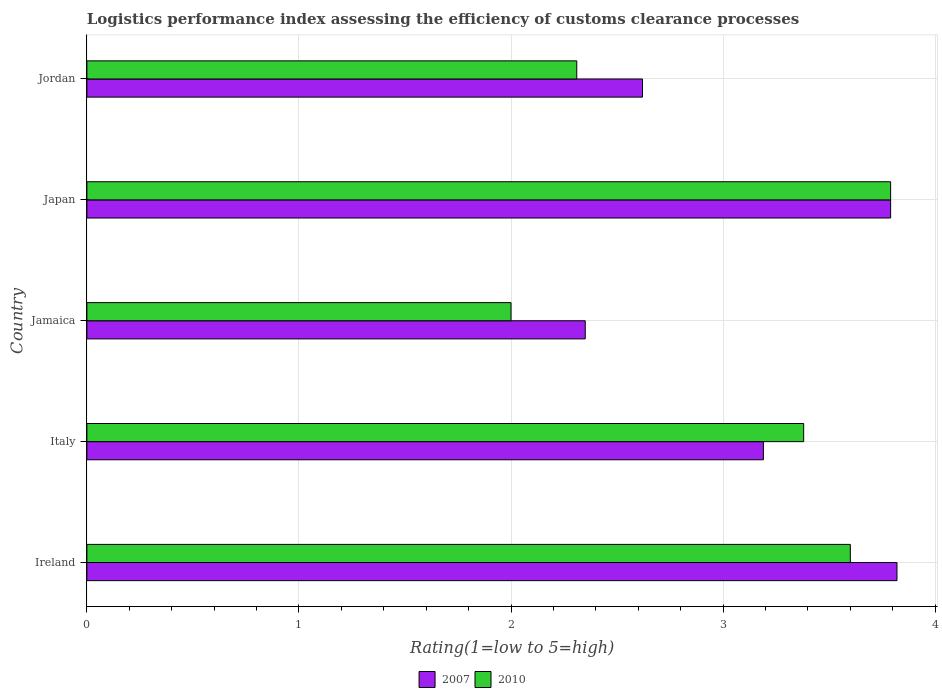How many different coloured bars are there?
Ensure brevity in your answer.  2. How many groups of bars are there?
Keep it short and to the point. 5. Are the number of bars per tick equal to the number of legend labels?
Offer a terse response. Yes. What is the label of the 5th group of bars from the top?
Provide a succinct answer. Ireland. What is the Logistic performance index in 2010 in Italy?
Offer a terse response. 3.38. Across all countries, what is the maximum Logistic performance index in 2010?
Make the answer very short. 3.79. In which country was the Logistic performance index in 2007 maximum?
Provide a short and direct response. Ireland. In which country was the Logistic performance index in 2007 minimum?
Give a very brief answer. Jamaica. What is the total Logistic performance index in 2007 in the graph?
Provide a succinct answer. 15.77. What is the difference between the Logistic performance index in 2010 in Italy and that in Jamaica?
Your answer should be very brief. 1.38. What is the difference between the Logistic performance index in 2007 in Jamaica and the Logistic performance index in 2010 in Jordan?
Provide a succinct answer. 0.04. What is the average Logistic performance index in 2007 per country?
Provide a short and direct response. 3.15. What is the difference between the Logistic performance index in 2007 and Logistic performance index in 2010 in Jordan?
Provide a short and direct response. 0.31. In how many countries, is the Logistic performance index in 2010 greater than 3.2 ?
Your answer should be very brief. 3. What is the ratio of the Logistic performance index in 2007 in Italy to that in Japan?
Provide a succinct answer. 0.84. Is the Logistic performance index in 2007 in Jamaica less than that in Jordan?
Keep it short and to the point. Yes. What is the difference between the highest and the second highest Logistic performance index in 2007?
Ensure brevity in your answer.  0.03. What is the difference between the highest and the lowest Logistic performance index in 2010?
Ensure brevity in your answer.  1.79. What does the 1st bar from the top in Jordan represents?
Give a very brief answer. 2010. How many bars are there?
Provide a short and direct response. 10. Are all the bars in the graph horizontal?
Make the answer very short. Yes. How many countries are there in the graph?
Your answer should be very brief. 5. Does the graph contain any zero values?
Keep it short and to the point. No. Does the graph contain grids?
Ensure brevity in your answer.  Yes. Where does the legend appear in the graph?
Provide a succinct answer. Bottom center. How are the legend labels stacked?
Offer a terse response. Horizontal. What is the title of the graph?
Ensure brevity in your answer.  Logistics performance index assessing the efficiency of customs clearance processes. Does "1963" appear as one of the legend labels in the graph?
Provide a succinct answer. No. What is the label or title of the X-axis?
Your response must be concise. Rating(1=low to 5=high). What is the Rating(1=low to 5=high) in 2007 in Ireland?
Your response must be concise. 3.82. What is the Rating(1=low to 5=high) in 2010 in Ireland?
Give a very brief answer. 3.6. What is the Rating(1=low to 5=high) in 2007 in Italy?
Keep it short and to the point. 3.19. What is the Rating(1=low to 5=high) in 2010 in Italy?
Offer a very short reply. 3.38. What is the Rating(1=low to 5=high) of 2007 in Jamaica?
Make the answer very short. 2.35. What is the Rating(1=low to 5=high) of 2010 in Jamaica?
Ensure brevity in your answer.  2. What is the Rating(1=low to 5=high) of 2007 in Japan?
Offer a very short reply. 3.79. What is the Rating(1=low to 5=high) in 2010 in Japan?
Make the answer very short. 3.79. What is the Rating(1=low to 5=high) in 2007 in Jordan?
Make the answer very short. 2.62. What is the Rating(1=low to 5=high) of 2010 in Jordan?
Make the answer very short. 2.31. Across all countries, what is the maximum Rating(1=low to 5=high) in 2007?
Ensure brevity in your answer.  3.82. Across all countries, what is the maximum Rating(1=low to 5=high) in 2010?
Provide a succinct answer. 3.79. Across all countries, what is the minimum Rating(1=low to 5=high) in 2007?
Provide a short and direct response. 2.35. Across all countries, what is the minimum Rating(1=low to 5=high) in 2010?
Your answer should be compact. 2. What is the total Rating(1=low to 5=high) of 2007 in the graph?
Offer a very short reply. 15.77. What is the total Rating(1=low to 5=high) of 2010 in the graph?
Offer a terse response. 15.08. What is the difference between the Rating(1=low to 5=high) of 2007 in Ireland and that in Italy?
Offer a terse response. 0.63. What is the difference between the Rating(1=low to 5=high) in 2010 in Ireland and that in Italy?
Keep it short and to the point. 0.22. What is the difference between the Rating(1=low to 5=high) in 2007 in Ireland and that in Jamaica?
Your answer should be compact. 1.47. What is the difference between the Rating(1=low to 5=high) in 2010 in Ireland and that in Jamaica?
Ensure brevity in your answer.  1.6. What is the difference between the Rating(1=low to 5=high) in 2010 in Ireland and that in Japan?
Your response must be concise. -0.19. What is the difference between the Rating(1=low to 5=high) of 2010 in Ireland and that in Jordan?
Your answer should be compact. 1.29. What is the difference between the Rating(1=low to 5=high) in 2007 in Italy and that in Jamaica?
Your answer should be compact. 0.84. What is the difference between the Rating(1=low to 5=high) in 2010 in Italy and that in Jamaica?
Ensure brevity in your answer.  1.38. What is the difference between the Rating(1=low to 5=high) of 2010 in Italy and that in Japan?
Your answer should be compact. -0.41. What is the difference between the Rating(1=low to 5=high) of 2007 in Italy and that in Jordan?
Keep it short and to the point. 0.57. What is the difference between the Rating(1=low to 5=high) in 2010 in Italy and that in Jordan?
Your response must be concise. 1.07. What is the difference between the Rating(1=low to 5=high) of 2007 in Jamaica and that in Japan?
Your answer should be compact. -1.44. What is the difference between the Rating(1=low to 5=high) of 2010 in Jamaica and that in Japan?
Your answer should be very brief. -1.79. What is the difference between the Rating(1=low to 5=high) in 2007 in Jamaica and that in Jordan?
Make the answer very short. -0.27. What is the difference between the Rating(1=low to 5=high) of 2010 in Jamaica and that in Jordan?
Give a very brief answer. -0.31. What is the difference between the Rating(1=low to 5=high) of 2007 in Japan and that in Jordan?
Your answer should be very brief. 1.17. What is the difference between the Rating(1=low to 5=high) of 2010 in Japan and that in Jordan?
Your answer should be very brief. 1.48. What is the difference between the Rating(1=low to 5=high) in 2007 in Ireland and the Rating(1=low to 5=high) in 2010 in Italy?
Your response must be concise. 0.44. What is the difference between the Rating(1=low to 5=high) of 2007 in Ireland and the Rating(1=low to 5=high) of 2010 in Jamaica?
Give a very brief answer. 1.82. What is the difference between the Rating(1=low to 5=high) of 2007 in Ireland and the Rating(1=low to 5=high) of 2010 in Japan?
Provide a short and direct response. 0.03. What is the difference between the Rating(1=low to 5=high) of 2007 in Ireland and the Rating(1=low to 5=high) of 2010 in Jordan?
Keep it short and to the point. 1.51. What is the difference between the Rating(1=low to 5=high) in 2007 in Italy and the Rating(1=low to 5=high) in 2010 in Jamaica?
Ensure brevity in your answer.  1.19. What is the difference between the Rating(1=low to 5=high) of 2007 in Italy and the Rating(1=low to 5=high) of 2010 in Jordan?
Your answer should be compact. 0.88. What is the difference between the Rating(1=low to 5=high) of 2007 in Jamaica and the Rating(1=low to 5=high) of 2010 in Japan?
Give a very brief answer. -1.44. What is the difference between the Rating(1=low to 5=high) of 2007 in Japan and the Rating(1=low to 5=high) of 2010 in Jordan?
Give a very brief answer. 1.48. What is the average Rating(1=low to 5=high) of 2007 per country?
Offer a very short reply. 3.15. What is the average Rating(1=low to 5=high) of 2010 per country?
Keep it short and to the point. 3.02. What is the difference between the Rating(1=low to 5=high) of 2007 and Rating(1=low to 5=high) of 2010 in Ireland?
Offer a terse response. 0.22. What is the difference between the Rating(1=low to 5=high) in 2007 and Rating(1=low to 5=high) in 2010 in Italy?
Ensure brevity in your answer.  -0.19. What is the difference between the Rating(1=low to 5=high) in 2007 and Rating(1=low to 5=high) in 2010 in Japan?
Provide a short and direct response. 0. What is the difference between the Rating(1=low to 5=high) in 2007 and Rating(1=low to 5=high) in 2010 in Jordan?
Offer a terse response. 0.31. What is the ratio of the Rating(1=low to 5=high) in 2007 in Ireland to that in Italy?
Make the answer very short. 1.2. What is the ratio of the Rating(1=low to 5=high) in 2010 in Ireland to that in Italy?
Ensure brevity in your answer.  1.07. What is the ratio of the Rating(1=low to 5=high) in 2007 in Ireland to that in Jamaica?
Offer a terse response. 1.63. What is the ratio of the Rating(1=low to 5=high) in 2007 in Ireland to that in Japan?
Your answer should be compact. 1.01. What is the ratio of the Rating(1=low to 5=high) in 2010 in Ireland to that in Japan?
Provide a short and direct response. 0.95. What is the ratio of the Rating(1=low to 5=high) in 2007 in Ireland to that in Jordan?
Your answer should be compact. 1.46. What is the ratio of the Rating(1=low to 5=high) of 2010 in Ireland to that in Jordan?
Ensure brevity in your answer.  1.56. What is the ratio of the Rating(1=low to 5=high) of 2007 in Italy to that in Jamaica?
Offer a very short reply. 1.36. What is the ratio of the Rating(1=low to 5=high) in 2010 in Italy to that in Jamaica?
Ensure brevity in your answer.  1.69. What is the ratio of the Rating(1=low to 5=high) of 2007 in Italy to that in Japan?
Provide a succinct answer. 0.84. What is the ratio of the Rating(1=low to 5=high) in 2010 in Italy to that in Japan?
Keep it short and to the point. 0.89. What is the ratio of the Rating(1=low to 5=high) of 2007 in Italy to that in Jordan?
Offer a terse response. 1.22. What is the ratio of the Rating(1=low to 5=high) in 2010 in Italy to that in Jordan?
Offer a terse response. 1.46. What is the ratio of the Rating(1=low to 5=high) in 2007 in Jamaica to that in Japan?
Make the answer very short. 0.62. What is the ratio of the Rating(1=low to 5=high) in 2010 in Jamaica to that in Japan?
Your answer should be compact. 0.53. What is the ratio of the Rating(1=low to 5=high) in 2007 in Jamaica to that in Jordan?
Your response must be concise. 0.9. What is the ratio of the Rating(1=low to 5=high) of 2010 in Jamaica to that in Jordan?
Your answer should be very brief. 0.87. What is the ratio of the Rating(1=low to 5=high) of 2007 in Japan to that in Jordan?
Keep it short and to the point. 1.45. What is the ratio of the Rating(1=low to 5=high) in 2010 in Japan to that in Jordan?
Your answer should be very brief. 1.64. What is the difference between the highest and the second highest Rating(1=low to 5=high) in 2007?
Offer a very short reply. 0.03. What is the difference between the highest and the second highest Rating(1=low to 5=high) of 2010?
Ensure brevity in your answer.  0.19. What is the difference between the highest and the lowest Rating(1=low to 5=high) in 2007?
Make the answer very short. 1.47. What is the difference between the highest and the lowest Rating(1=low to 5=high) in 2010?
Make the answer very short. 1.79. 